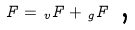<formula> <loc_0><loc_0><loc_500><loc_500>F = \, _ { v } F + \, _ { g } F \text { ,}</formula> 